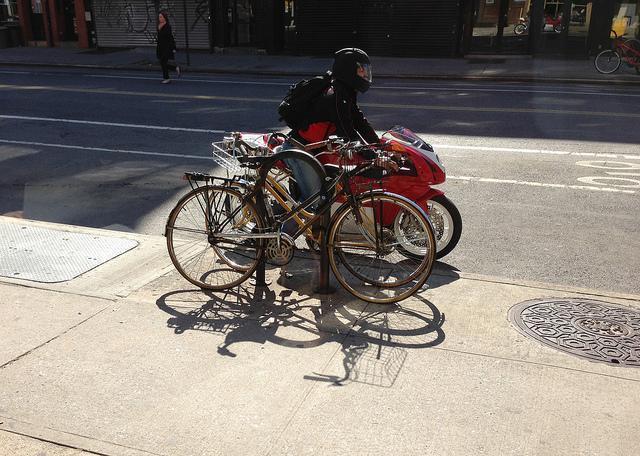In which lane does the person in the black helmet ride?
Pick the correct solution from the four options below to address the question.
Options: Dirt lane, right lane, median lane, bike lane. Right lane. 